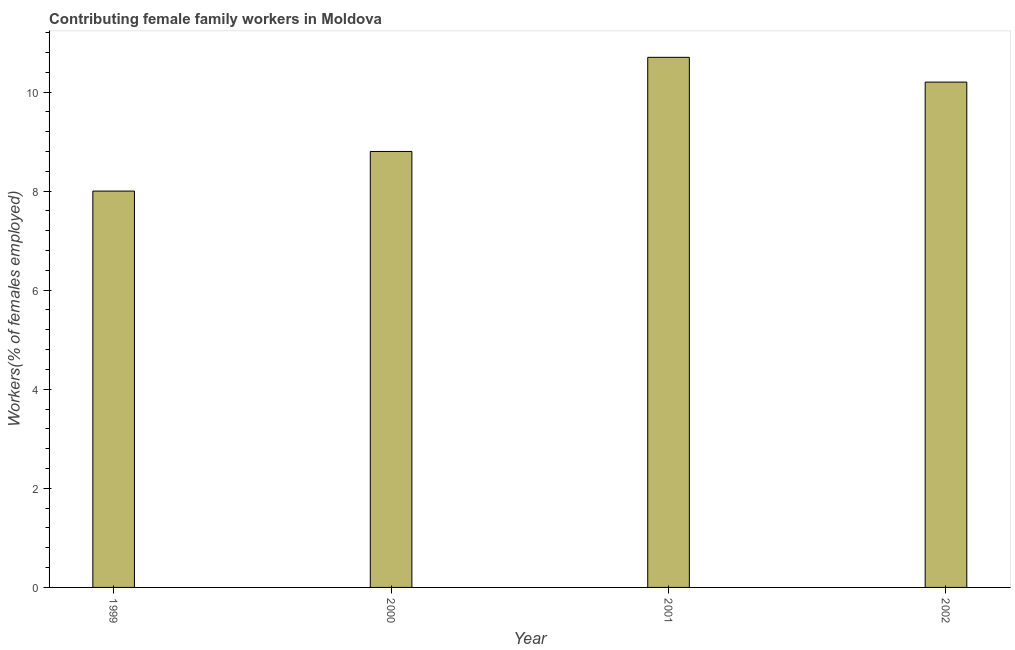Does the graph contain any zero values?
Give a very brief answer. No. What is the title of the graph?
Your response must be concise. Contributing female family workers in Moldova. What is the label or title of the X-axis?
Provide a short and direct response. Year. What is the label or title of the Y-axis?
Make the answer very short. Workers(% of females employed). What is the contributing female family workers in 2002?
Give a very brief answer. 10.2. Across all years, what is the maximum contributing female family workers?
Keep it short and to the point. 10.7. In which year was the contributing female family workers minimum?
Offer a very short reply. 1999. What is the sum of the contributing female family workers?
Your response must be concise. 37.7. What is the average contributing female family workers per year?
Offer a very short reply. 9.43. What is the median contributing female family workers?
Your answer should be very brief. 9.5. In how many years, is the contributing female family workers greater than 6.4 %?
Ensure brevity in your answer.  4. Do a majority of the years between 2002 and 2000 (inclusive) have contributing female family workers greater than 6.8 %?
Make the answer very short. Yes. What is the ratio of the contributing female family workers in 2000 to that in 2001?
Make the answer very short. 0.82. Is the difference between the contributing female family workers in 1999 and 2002 greater than the difference between any two years?
Your response must be concise. No. How many bars are there?
Ensure brevity in your answer.  4. How many years are there in the graph?
Keep it short and to the point. 4. Are the values on the major ticks of Y-axis written in scientific E-notation?
Your answer should be very brief. No. What is the Workers(% of females employed) of 2000?
Your response must be concise. 8.8. What is the Workers(% of females employed) in 2001?
Your answer should be very brief. 10.7. What is the Workers(% of females employed) of 2002?
Your answer should be compact. 10.2. What is the difference between the Workers(% of females employed) in 1999 and 2000?
Give a very brief answer. -0.8. What is the difference between the Workers(% of females employed) in 1999 and 2001?
Your answer should be very brief. -2.7. What is the difference between the Workers(% of females employed) in 2000 and 2001?
Your answer should be compact. -1.9. What is the ratio of the Workers(% of females employed) in 1999 to that in 2000?
Your answer should be compact. 0.91. What is the ratio of the Workers(% of females employed) in 1999 to that in 2001?
Provide a short and direct response. 0.75. What is the ratio of the Workers(% of females employed) in 1999 to that in 2002?
Ensure brevity in your answer.  0.78. What is the ratio of the Workers(% of females employed) in 2000 to that in 2001?
Offer a very short reply. 0.82. What is the ratio of the Workers(% of females employed) in 2000 to that in 2002?
Ensure brevity in your answer.  0.86. What is the ratio of the Workers(% of females employed) in 2001 to that in 2002?
Give a very brief answer. 1.05. 